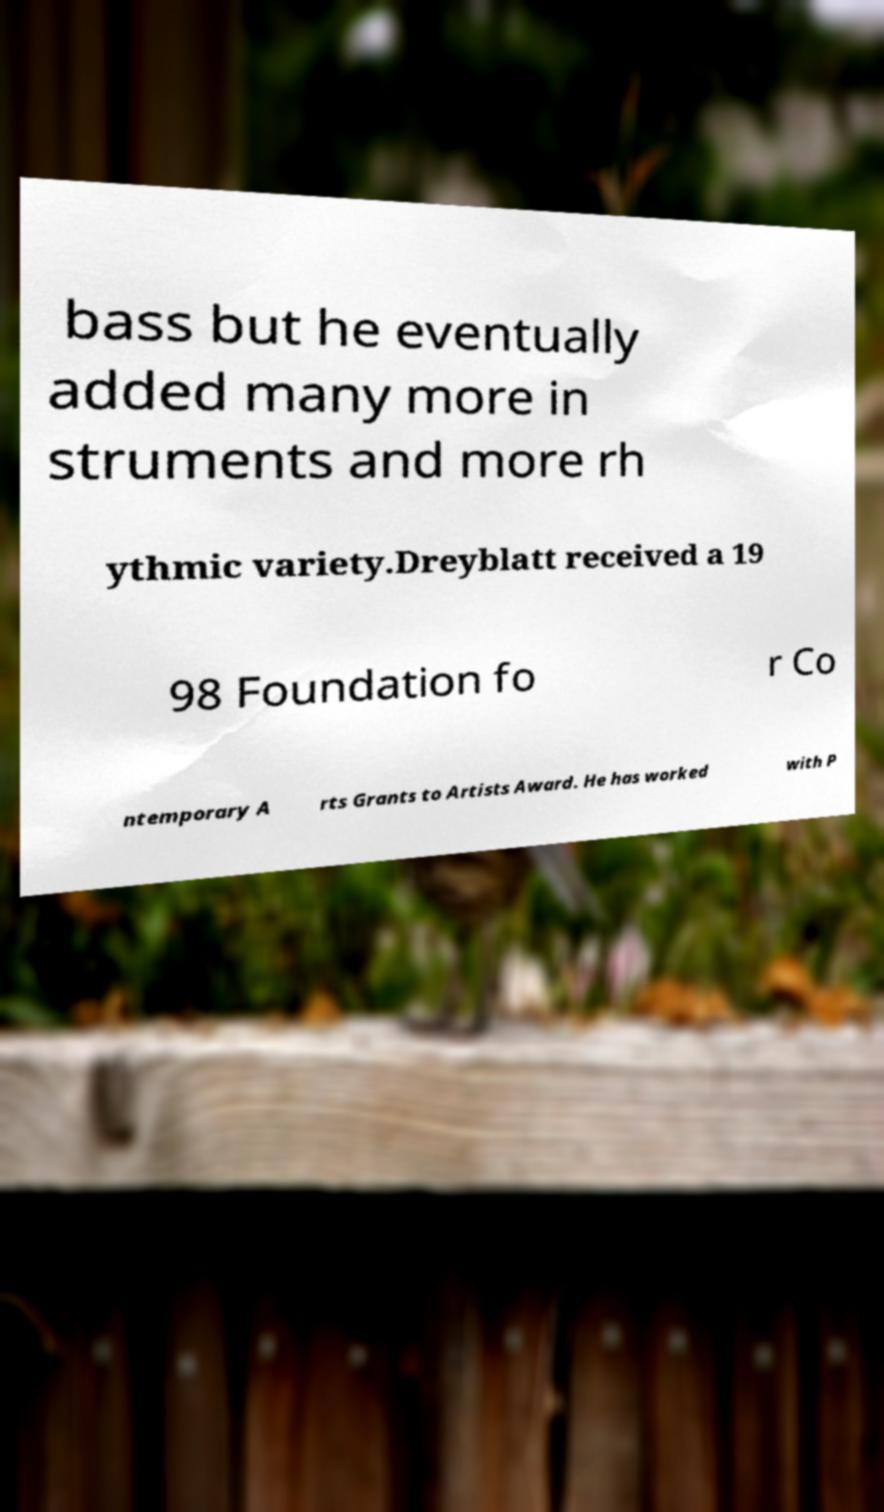I need the written content from this picture converted into text. Can you do that? bass but he eventually added many more in struments and more rh ythmic variety.Dreyblatt received a 19 98 Foundation fo r Co ntemporary A rts Grants to Artists Award. He has worked with P 